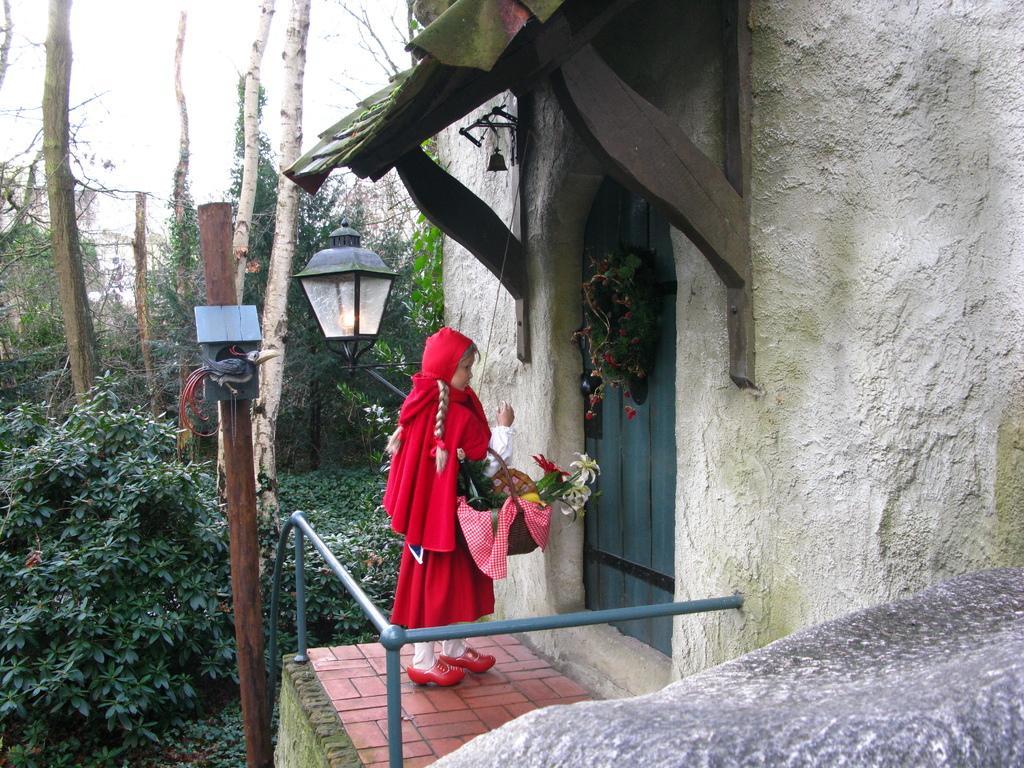Describe this image in one or two sentences. In this image we can see a girl is standing on the floor at the door and she is carrying a basket with flowers in it. We can also see railing, objects on a wooden pole, wall, objects and roof. In the background we can see trees and the sky. 